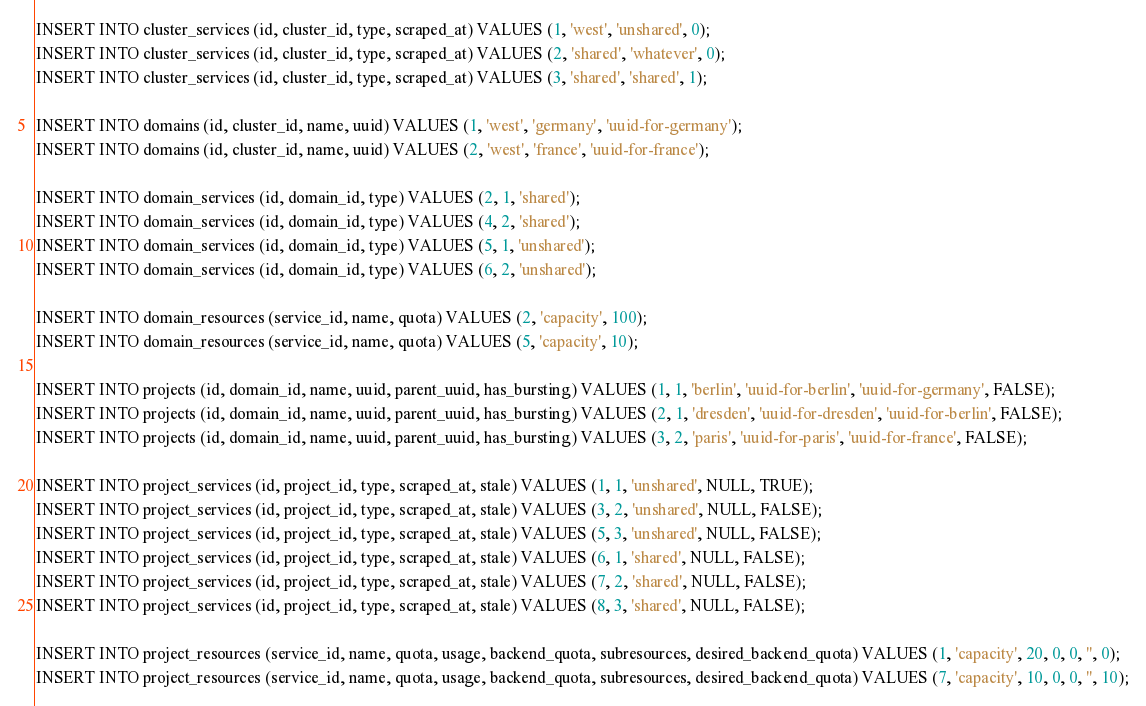<code> <loc_0><loc_0><loc_500><loc_500><_SQL_>INSERT INTO cluster_services (id, cluster_id, type, scraped_at) VALUES (1, 'west', 'unshared', 0);
INSERT INTO cluster_services (id, cluster_id, type, scraped_at) VALUES (2, 'shared', 'whatever', 0);
INSERT INTO cluster_services (id, cluster_id, type, scraped_at) VALUES (3, 'shared', 'shared', 1);

INSERT INTO domains (id, cluster_id, name, uuid) VALUES (1, 'west', 'germany', 'uuid-for-germany');
INSERT INTO domains (id, cluster_id, name, uuid) VALUES (2, 'west', 'france', 'uuid-for-france');

INSERT INTO domain_services (id, domain_id, type) VALUES (2, 1, 'shared');
INSERT INTO domain_services (id, domain_id, type) VALUES (4, 2, 'shared');
INSERT INTO domain_services (id, domain_id, type) VALUES (5, 1, 'unshared');
INSERT INTO domain_services (id, domain_id, type) VALUES (6, 2, 'unshared');

INSERT INTO domain_resources (service_id, name, quota) VALUES (2, 'capacity', 100);
INSERT INTO domain_resources (service_id, name, quota) VALUES (5, 'capacity', 10);

INSERT INTO projects (id, domain_id, name, uuid, parent_uuid, has_bursting) VALUES (1, 1, 'berlin', 'uuid-for-berlin', 'uuid-for-germany', FALSE);
INSERT INTO projects (id, domain_id, name, uuid, parent_uuid, has_bursting) VALUES (2, 1, 'dresden', 'uuid-for-dresden', 'uuid-for-berlin', FALSE);
INSERT INTO projects (id, domain_id, name, uuid, parent_uuid, has_bursting) VALUES (3, 2, 'paris', 'uuid-for-paris', 'uuid-for-france', FALSE);

INSERT INTO project_services (id, project_id, type, scraped_at, stale) VALUES (1, 1, 'unshared', NULL, TRUE);
INSERT INTO project_services (id, project_id, type, scraped_at, stale) VALUES (3, 2, 'unshared', NULL, FALSE);
INSERT INTO project_services (id, project_id, type, scraped_at, stale) VALUES (5, 3, 'unshared', NULL, FALSE);
INSERT INTO project_services (id, project_id, type, scraped_at, stale) VALUES (6, 1, 'shared', NULL, FALSE);
INSERT INTO project_services (id, project_id, type, scraped_at, stale) VALUES (7, 2, 'shared', NULL, FALSE);
INSERT INTO project_services (id, project_id, type, scraped_at, stale) VALUES (8, 3, 'shared', NULL, FALSE);

INSERT INTO project_resources (service_id, name, quota, usage, backend_quota, subresources, desired_backend_quota) VALUES (1, 'capacity', 20, 0, 0, '', 0);
INSERT INTO project_resources (service_id, name, quota, usage, backend_quota, subresources, desired_backend_quota) VALUES (7, 'capacity', 10, 0, 0, '', 10);
</code> 